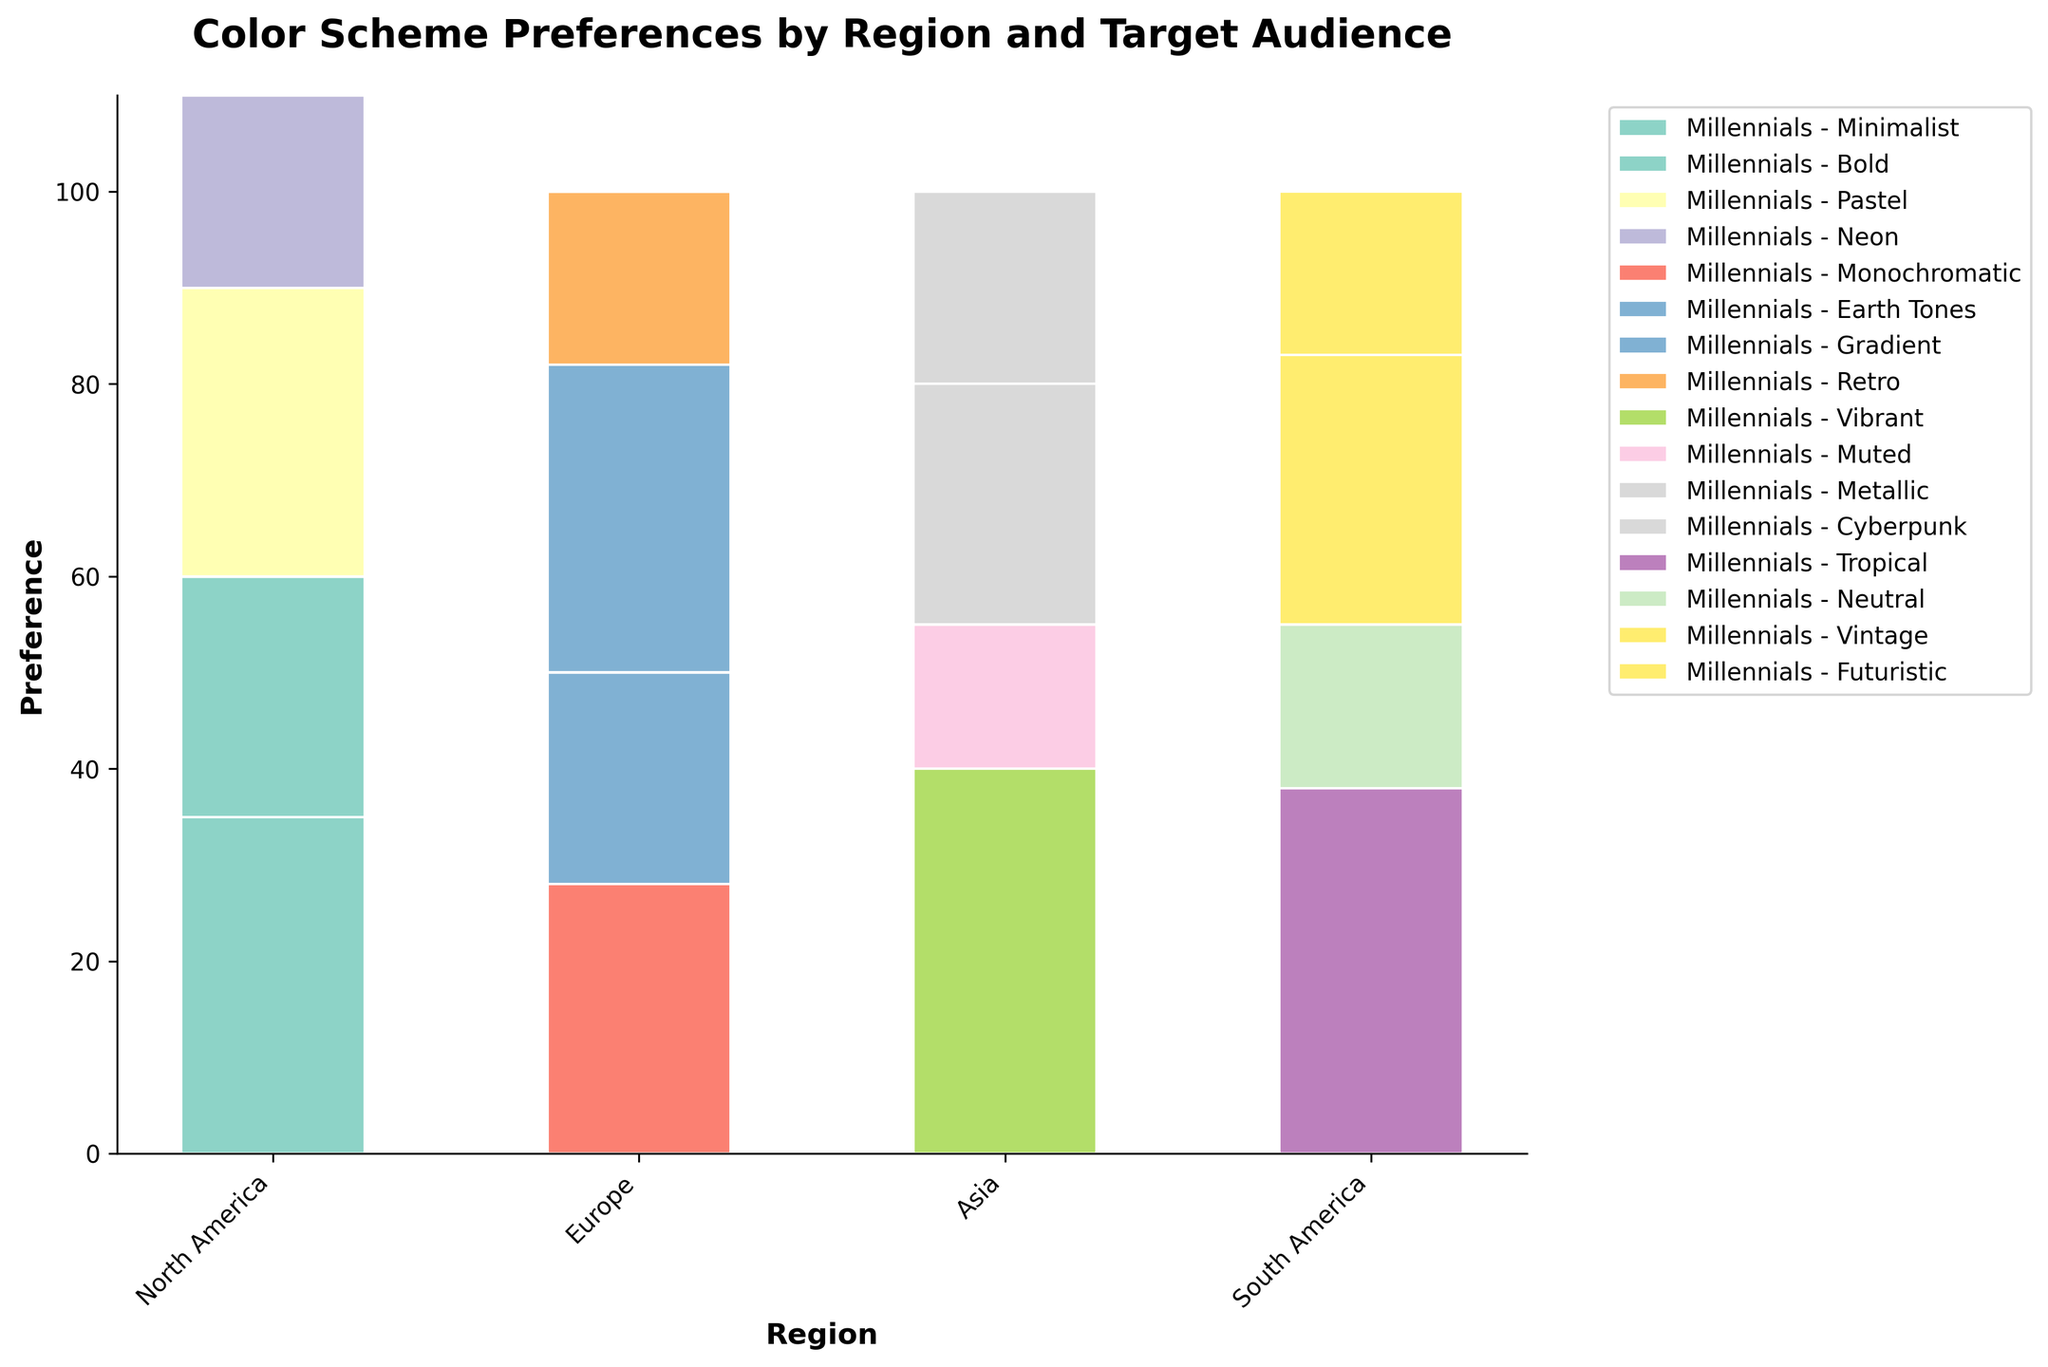What is the title of the plot? The title of the plot is located at the top of the figure. It summarizes the main focus of the plot.
Answer: Color Scheme Preferences by Region and Target Audience What is the color scheme preference of Millennials in North America with the highest value? To determine this, look at the segment corresponding to Millennials in North America and identify the color scheme with the tallest bar.
Answer: Minimalist Which region has the highest preference for the Cyberpunk color scheme? Look at the height of the bars associated with the Cyberpunk color scheme across all regions. The region with the tallest bar represents the highest preference.
Answer: Asia How do the color scheme preferences of Gen Z in Europe compare between Gradient and Retro? Compare the height of the bars corresponding to the Gradient and Retro color schemes for Gen Z in Europe. The taller bar indicates a higher preference.
Answer: Gradient is higher What is the combined preference for Monochromatic and Earth Tones among Millennials in Europe? Locate the bars for Monochromatic and Earth Tones in Europe for Millennials. Add their heights to find the combined preference.
Answer: 50 (28 + 22) Which color scheme has the least preference overall in South America? Check all the color scheme segments in South America. The shortest bar represents the least preference.
Answer: Futuristic What is the overarching trend among Millennials in terms of their preferred color scheme across all regions? Examine the heights of color scheme bars for Millennials across all regions to identify the color scheme consistently higher or more frequently chosen.
Answer: Minimalist and Tropical are popular How does the preference for Bold among Millennials in North America compare to Vibrant among Millennials in Asia? Compare the height of the Bold segment for Millennials in North America with the Vibrant segment for Millennials in Asia.
Answer: Vibrant in Asia is higher Which region shows the least preference for Earth Tones among Millennials? Identify the bars corresponding to Earth Tones for Millennials across all regions. The shortest bar indicates the least preference.
Answer: Not applicable, only Europe has Earth Tones Summing up the preferences for Pastel and Neon by Gen Z in North America. What is the total? Locate the bars for Pastel and Neon among Gen Z in North America. Add their heights to get the total preference.
Answer: 50 (30 + 20) 